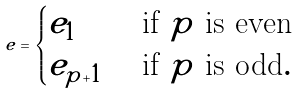<formula> <loc_0><loc_0><loc_500><loc_500>e = \begin{cases} e _ { 1 } & \text { if $p$ is even} \\ e _ { p + 1 } & \text { if $p$ is odd} . \end{cases}</formula> 